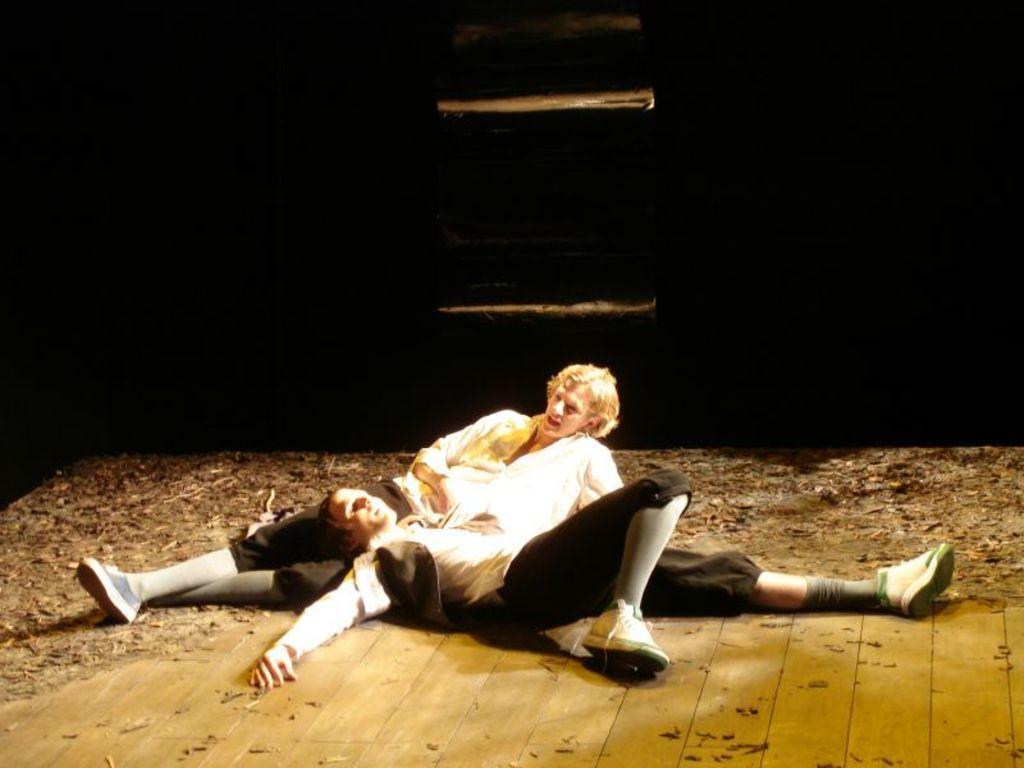Could you give a brief overview of what you see in this image? In this picture we can see two persons are lying, at the bottom we can see sawdust, there is a dark background. 